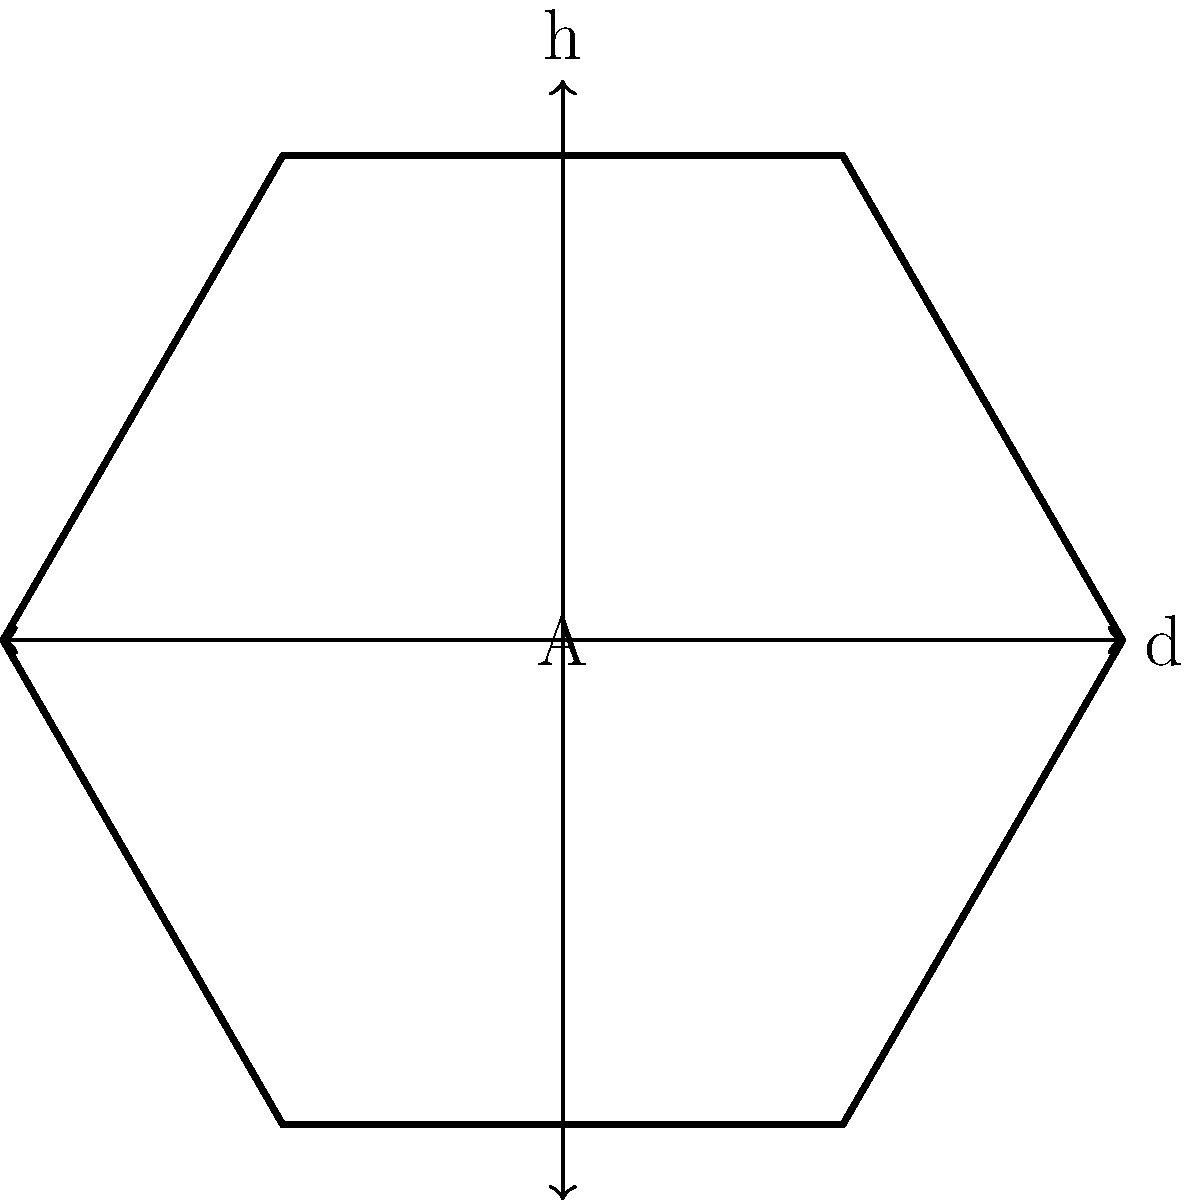In a military vehicle, a hexagonal bolt is used for its superior grip and resistance to stripping. The bolt has a diameter (d) of 12 mm across its flats. What is the cross-sectional area of this hexagonal bolt? To find the cross-sectional area of a hexagonal bolt, we can follow these steps:

1) First, recall the formula for the area of a regular hexagon:

   $$A = \frac{3\sqrt{3}}{2}r^2$$

   where $r$ is the radius of the circumscribed circle.

2) We're given the diameter across the flats (d), which is the distance between two parallel sides. We need to find the radius of the circumscribed circle (R).

3) The relationship between d and R in a regular hexagon is:

   $$R = \frac{d}{\sqrt{3}}$$

4) Substituting the given diameter:

   $$R = \frac{12}{\sqrt{3}} = 4\sqrt{3} \text{ mm}$$

5) Now we can use this in our area formula:

   $$A = \frac{3\sqrt{3}}{2}(4\sqrt{3})^2$$

6) Simplify:

   $$A = \frac{3\sqrt{3}}{2}(48) = 72\sqrt{3} \text{ mm}^2$$

Therefore, the cross-sectional area of the hexagonal bolt is $72\sqrt{3}$ square millimeters.
Answer: $72\sqrt{3} \text{ mm}^2$ 